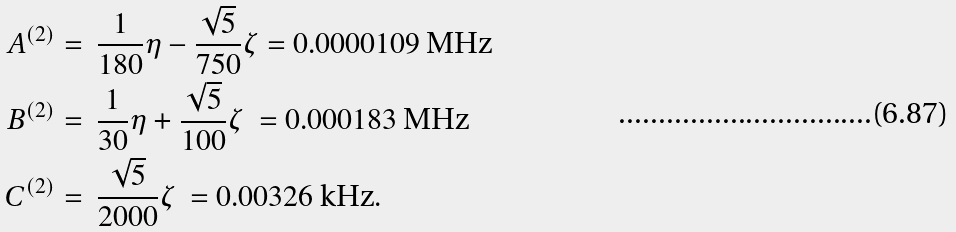<formula> <loc_0><loc_0><loc_500><loc_500>A ^ { ( 2 ) } & = \ \frac { 1 } { 1 8 0 } \eta - \frac { \sqrt { 5 } } { 7 5 0 } \zeta = 0 . 0 0 0 0 1 0 9 \ \text {MHz} \\ B ^ { ( 2 ) } & = \ \frac { 1 } { 3 0 } \eta + \frac { \sqrt { 5 } } { 1 0 0 } \zeta \ = 0 . 0 0 0 1 8 3 \ \text {MHz} \\ C ^ { ( 2 ) } & = \ \frac { \sqrt { 5 } } { 2 0 0 0 } \zeta \ = 0 . 0 0 3 2 6 \ \text {kHz} .</formula> 